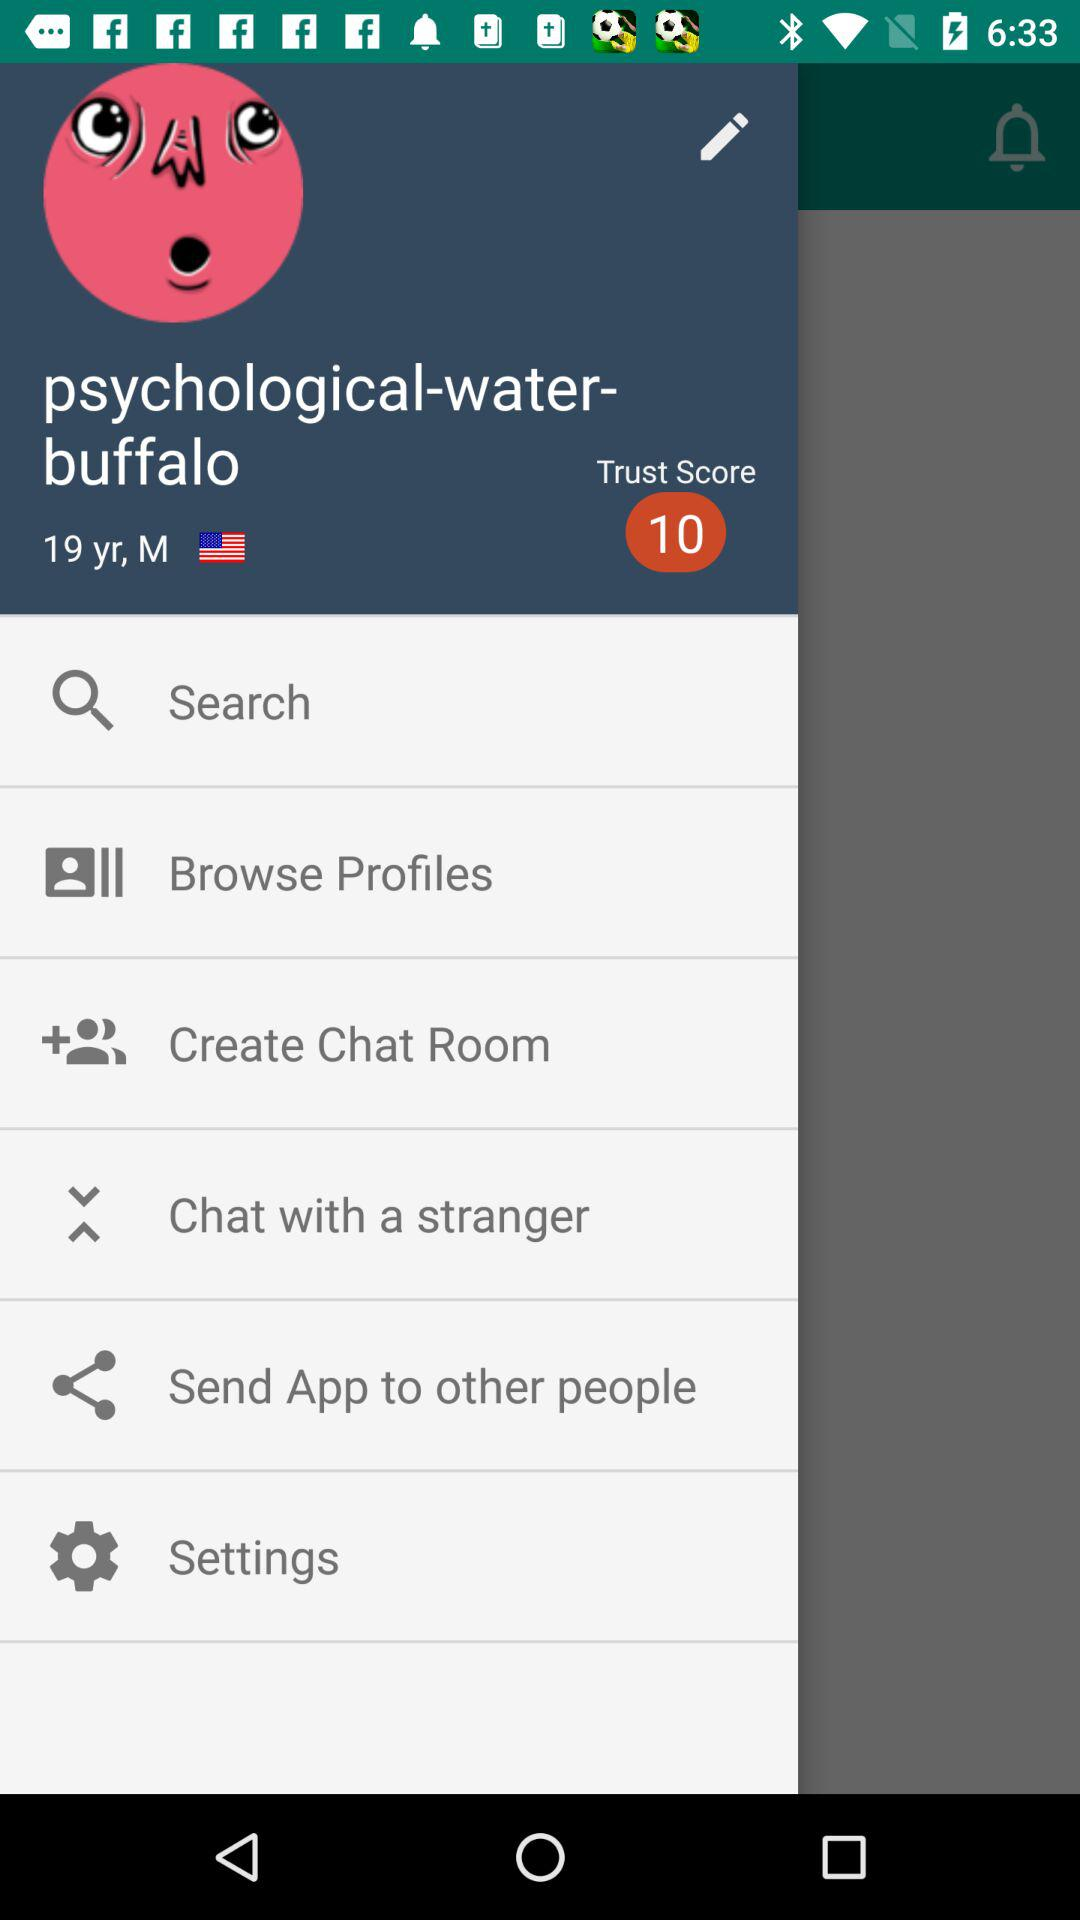What is the username? The username is "psychological-water-buffalo". 